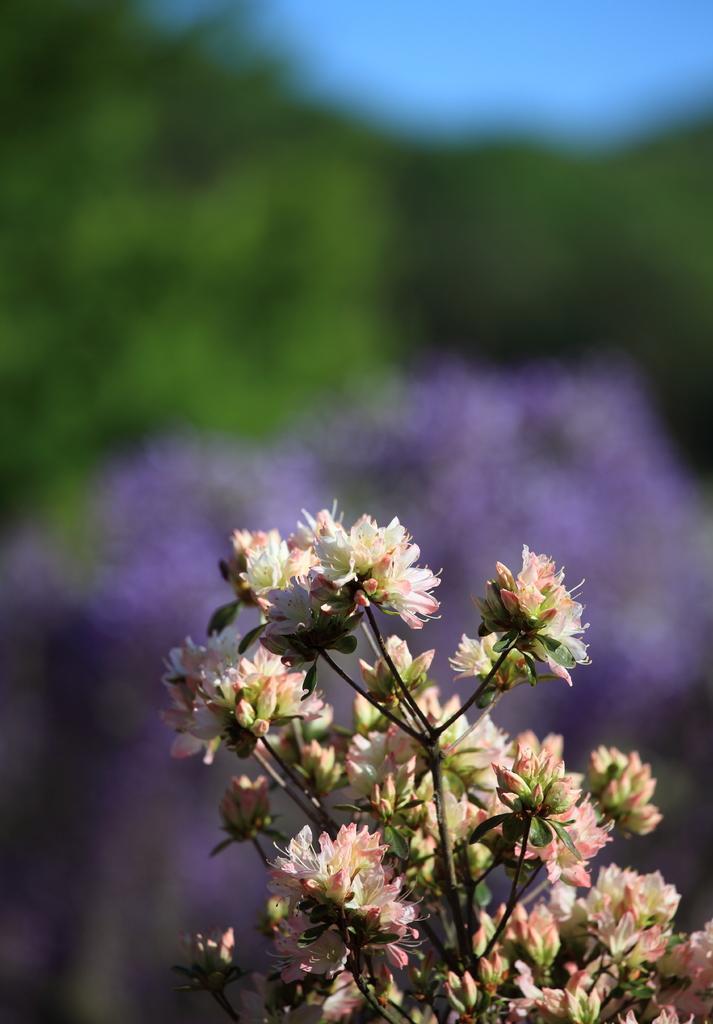Can you describe this image briefly? In this image I can see few flowers which are white and pink in color to a tree which is green in color. I can see the blurry background in which I can see few trees, the sky and few purple colored flowers. 